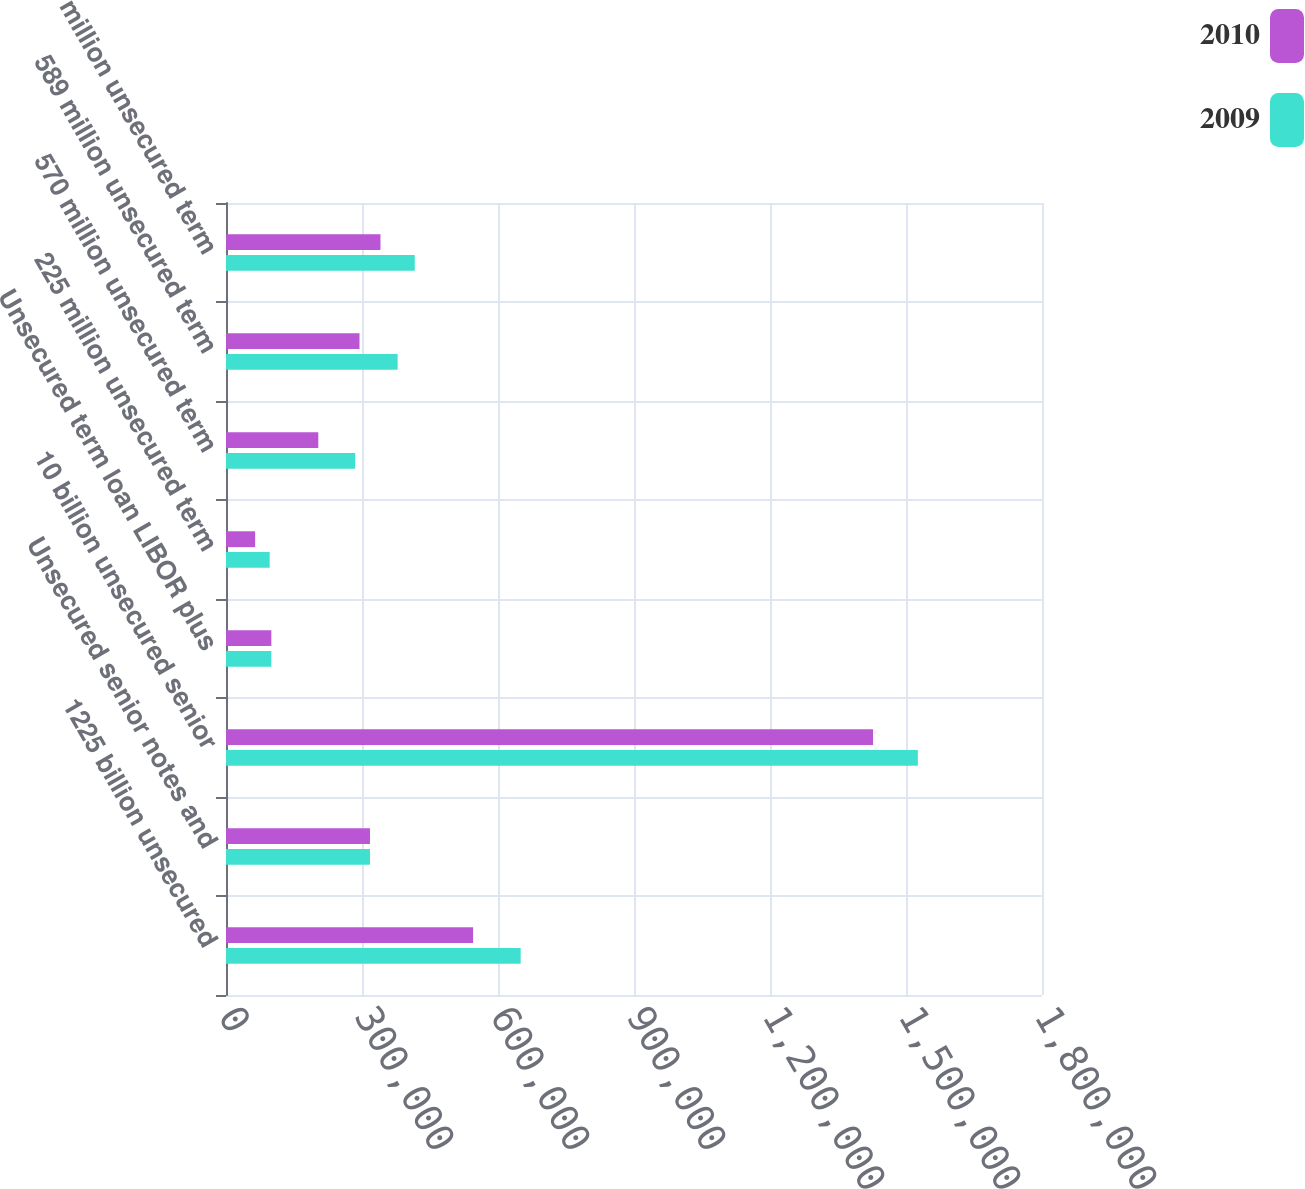Convert chart to OTSL. <chart><loc_0><loc_0><loc_500><loc_500><stacked_bar_chart><ecel><fcel>1225 billion unsecured<fcel>Unsecured senior notes and<fcel>10 billion unsecured senior<fcel>Unsecured term loan LIBOR plus<fcel>225 million unsecured term<fcel>570 million unsecured term<fcel>589 million unsecured term<fcel>530 million unsecured term<nl><fcel>2010<fcel>545000<fcel>317607<fcel>1.42732e+06<fcel>100000<fcel>64238<fcel>203571<fcel>294500<fcel>340714<nl><fcel>2009<fcel>650000<fcel>317607<fcel>1.52613e+06<fcel>100000<fcel>96390<fcel>285000<fcel>378643<fcel>416429<nl></chart> 